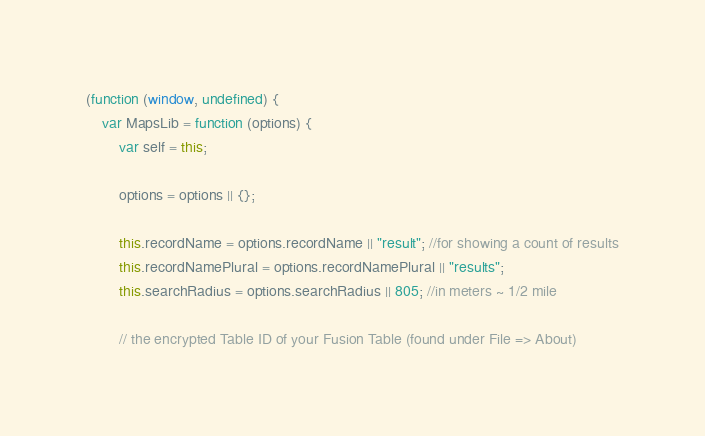<code> <loc_0><loc_0><loc_500><loc_500><_JavaScript_>(function (window, undefined) {
    var MapsLib = function (options) {
        var self = this;

        options = options || {};

        this.recordName = options.recordName || "result"; //for showing a count of results
        this.recordNamePlural = options.recordNamePlural || "results";
        this.searchRadius = options.searchRadius || 805; //in meters ~ 1/2 mile

        // the encrypted Table ID of your Fusion Table (found under File => About)</code> 